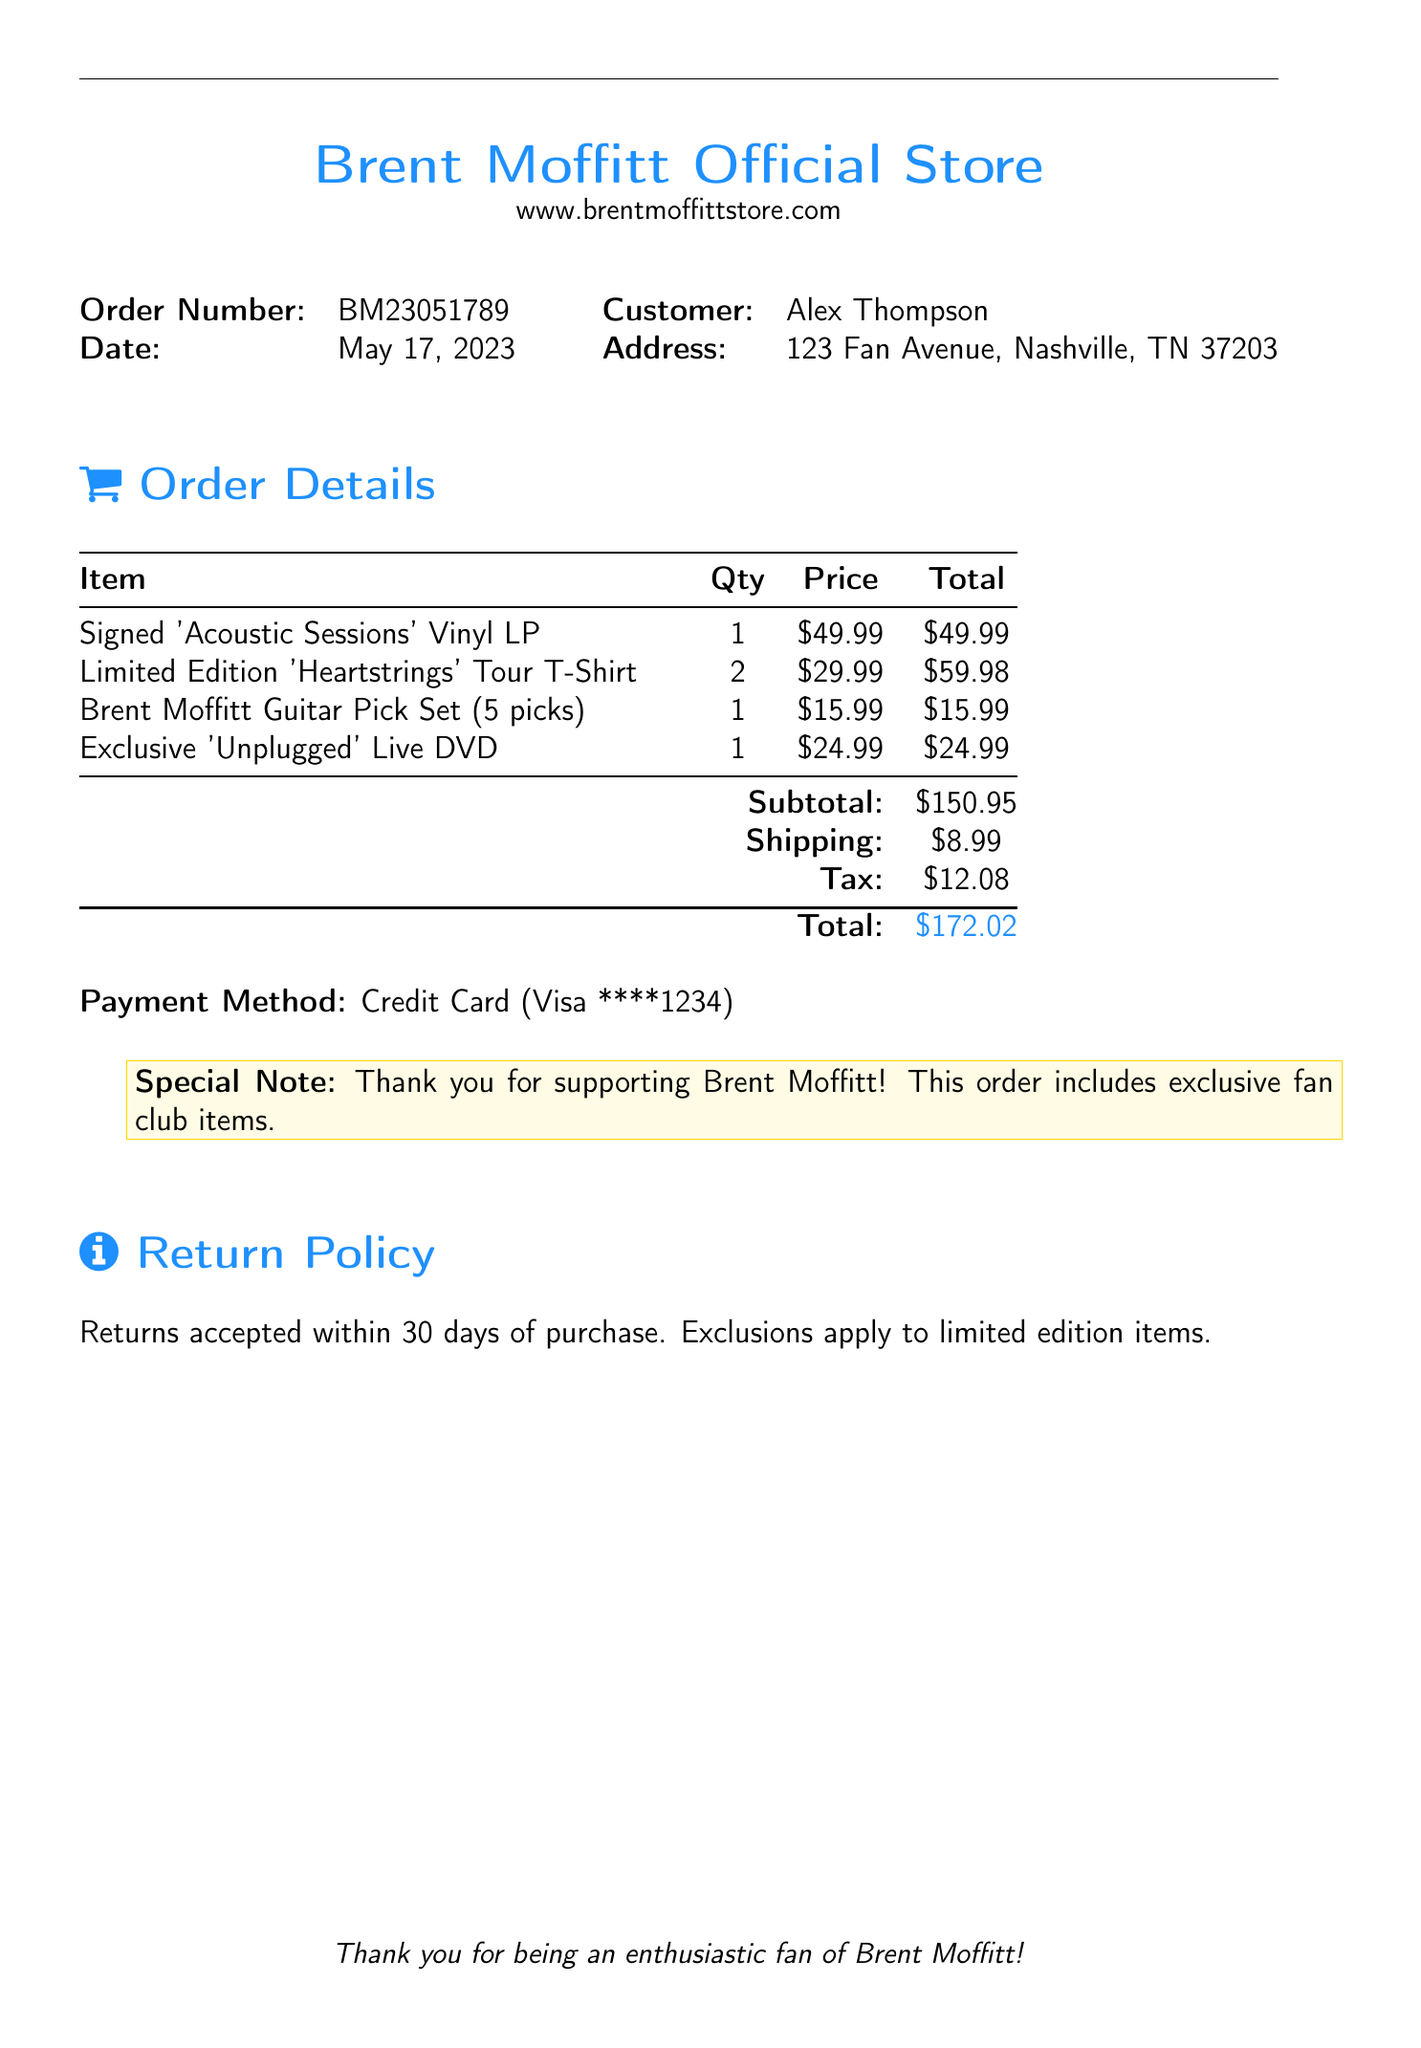What is the order number? The order number is listed at the top of the document.
Answer: BM23051789 What is the date of the order? The date of the order appears next to the order number.
Answer: May 17, 2023 Who is the customer? The customer's name is provided near the top of the document.
Answer: Alex Thompson How many 'Heartstrings' Tour T-Shirts were ordered? The quantity of the T-shirts can be found in the order details.
Answer: 2 What is the subtotal of the order? The subtotal is calculated total of the items before additional costs.
Answer: $150.95 What is the total amount to be paid? The total amount is the final figure at the bottom of the order summary.
Answer: $172.02 What payment method was used? The payment method is specified in the payment section of the document.
Answer: Credit Card (Visa ****1234) Is there a return policy mentioned? The document includes a return policy section outlining the terms.
Answer: Yes What is the special note in the order? The special note is included in a highlighted box thanking the customer.
Answer: Thank you for supporting Brent Moffitt! This order includes exclusive fan club items 